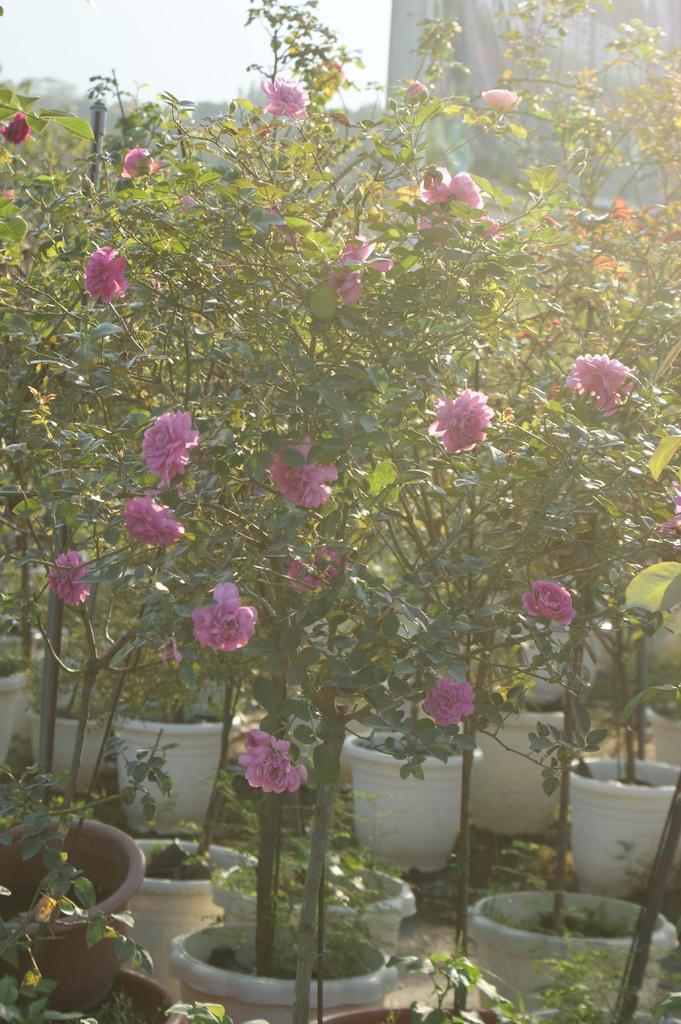How would you summarize this image in a sentence or two? This picture is clicked outside. In the foreground we can see the plants in the pots and the flowers which are pink in color. In the background there is a sky and some other object. 